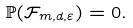<formula> <loc_0><loc_0><loc_500><loc_500>\mathbb { P } ( \mathcal { F } _ { m , d , \varepsilon } ) = 0 .</formula> 